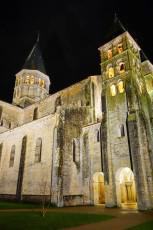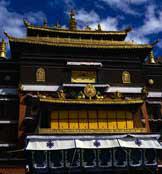The first image is the image on the left, the second image is the image on the right. Examine the images to the left and right. Is the description "There is a conical roof in one of the images." accurate? Answer yes or no. Yes. The first image is the image on the left, the second image is the image on the right. Evaluate the accuracy of this statement regarding the images: "At least one image shows a building with a cone-shape atop a cylinder.". Is it true? Answer yes or no. Yes. 